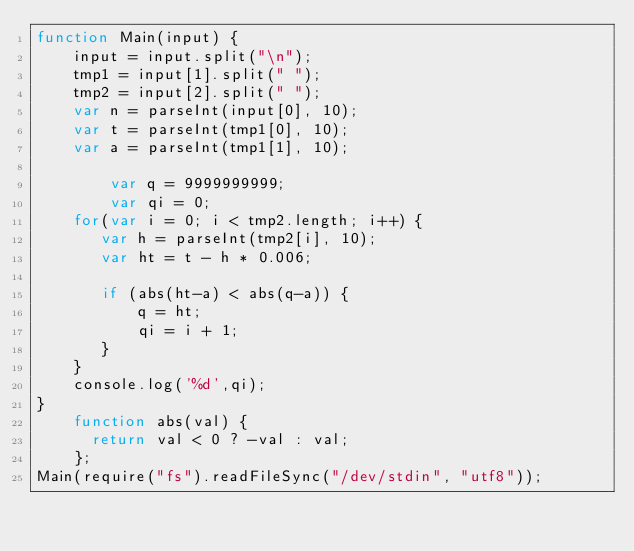Convert code to text. <code><loc_0><loc_0><loc_500><loc_500><_JavaScript_>function Main(input) {
	input = input.split("\n");
	tmp1 = input[1].split(" ");
	tmp2 = input[2].split(" ");
	var n = parseInt(input[0], 10);
	var t = parseInt(tmp1[0], 10);
	var a = parseInt(tmp1[1], 10);

        var q = 9999999999;
        var qi = 0;
	for(var i = 0; i < tmp2.length; i++) {
	   var h = parseInt(tmp2[i], 10);
	   var ht = t - h * 0.006;
	   
       if (abs(ht-a) < abs(q-a)) {
           q = ht;
           qi = i + 1;
       }
	}
	console.log('%d',qi);
}
	function abs(val) {
	  return val < 0 ? -val : val;
	};
Main(require("fs").readFileSync("/dev/stdin", "utf8"));</code> 